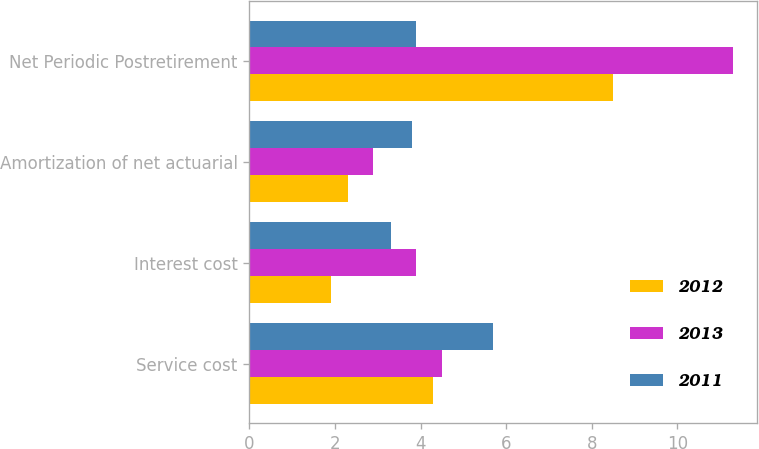Convert chart to OTSL. <chart><loc_0><loc_0><loc_500><loc_500><stacked_bar_chart><ecel><fcel>Service cost<fcel>Interest cost<fcel>Amortization of net actuarial<fcel>Net Periodic Postretirement<nl><fcel>2012<fcel>4.3<fcel>1.9<fcel>2.3<fcel>8.5<nl><fcel>2013<fcel>4.5<fcel>3.9<fcel>2.9<fcel>11.3<nl><fcel>2011<fcel>5.7<fcel>3.3<fcel>3.8<fcel>3.9<nl></chart> 